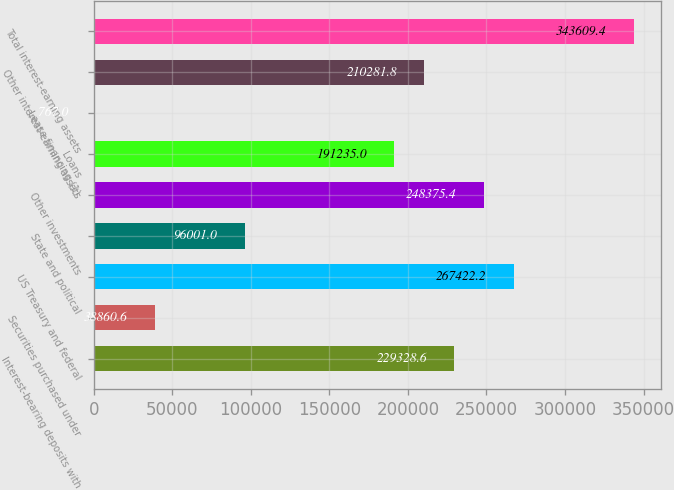<chart> <loc_0><loc_0><loc_500><loc_500><bar_chart><fcel>Interest-bearing deposits with<fcel>Securities purchased under<fcel>US Treasury and federal<fcel>State and political<fcel>Other investments<fcel>Loans<fcel>Lease financing (1)<fcel>Other interest-earning assets<fcel>Total interest-earning assets<nl><fcel>229329<fcel>38860.6<fcel>267422<fcel>96001<fcel>248375<fcel>191235<fcel>767<fcel>210282<fcel>343609<nl></chart> 